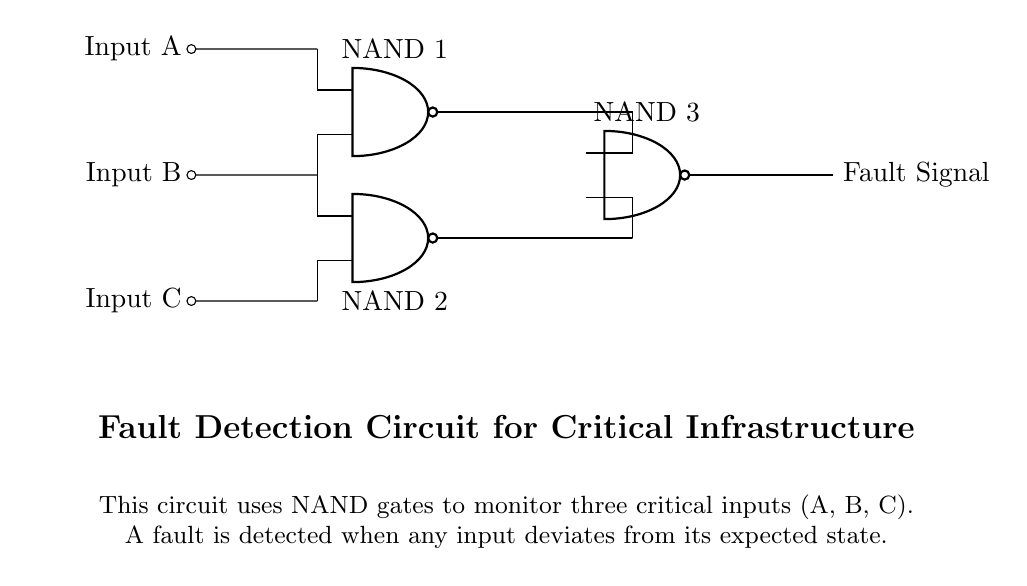What are the inputs indicated in the circuit? The inputs indicated in the circuit are Input A, Input B, and Input C, as labeled on the left side of the diagram.
Answer: Input A, Input B, Input C How many NAND gates are used in this circuit? The circuit contains three NAND gates, as shown by the three symbols labeled NAND 1, NAND 2, and NAND 3 in the diagram.
Answer: Three What is the output of the circuit called? The output of the circuit is labeled as Fault Signal, indicating that it is used to indicate any fault detected based on the inputs.
Answer: Fault Signal What is the primary function of this fault detection circuit? The primary function of this circuit is to monitor the three critical inputs and detect any faults when these inputs deviate from their expected state, as described in the description section.
Answer: Monitor inputs and detect faults How does NAND 1 relate to the other gates in the circuit? NAND 1 takes Inputs A and B as its inputs, processes them, and its output connects to NAND 3, indicating that its result is considered in the final fault detection.
Answer: Connects to NAND 3 What condition results in a Fault Signal being generated? A Fault Signal is generated when any of the inputs (A, B, C) deviate from their expected state, as indicated in the description explaining the purpose of the circuit.
Answer: Any input deviation 